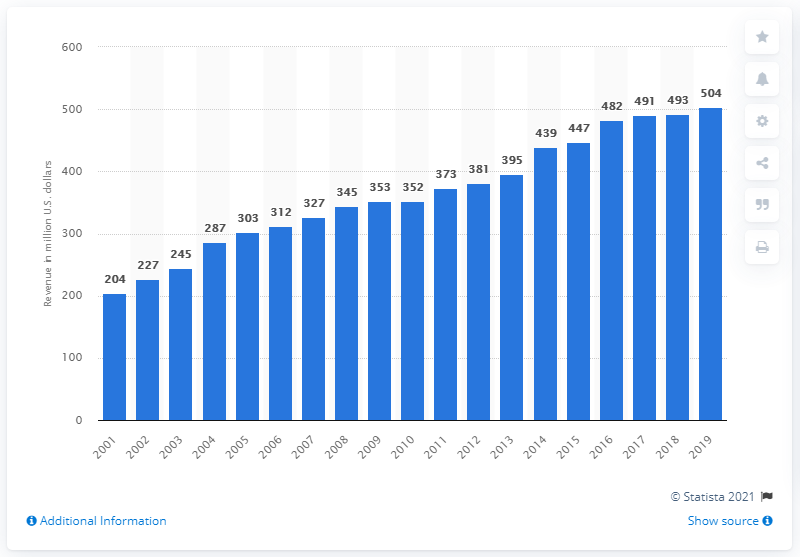Point out several critical features in this image. The revenue of the Washington Football Team in 2019 was 504. 